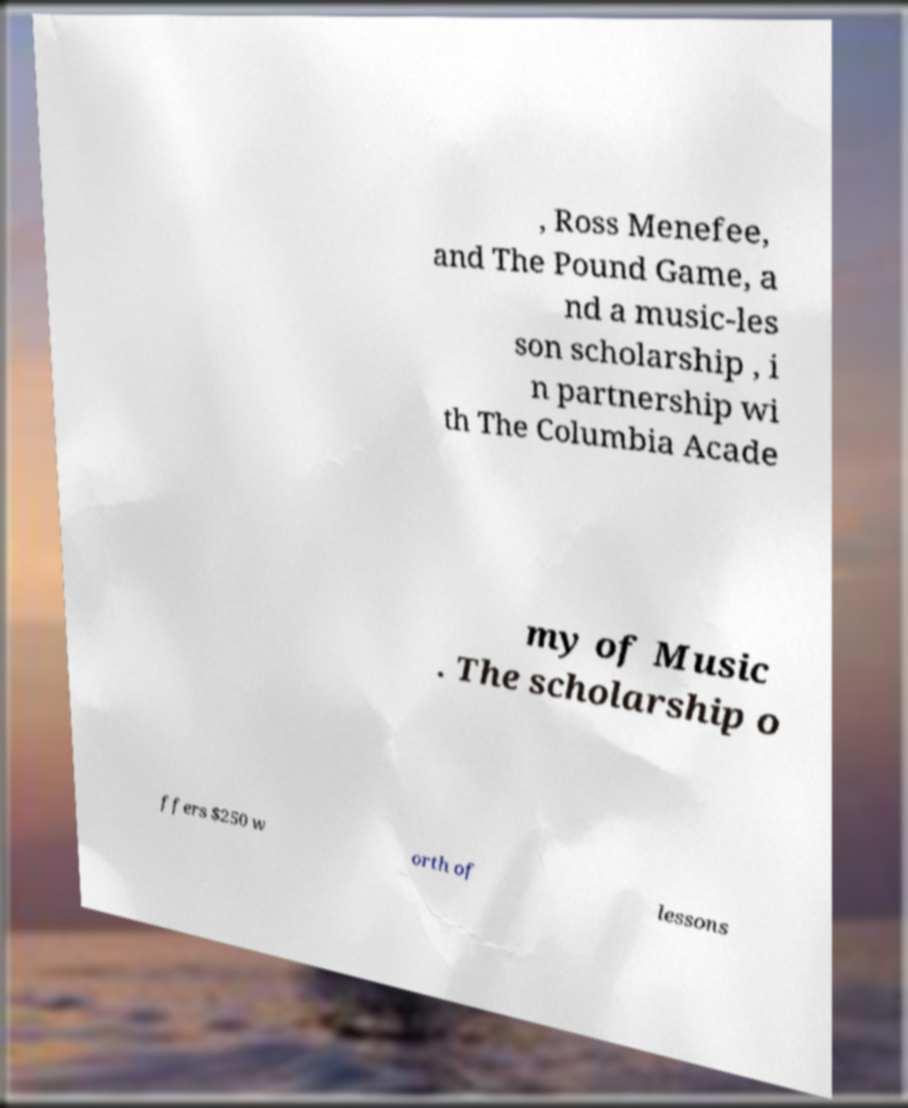For documentation purposes, I need the text within this image transcribed. Could you provide that? , Ross Menefee, and The Pound Game, a nd a music-les son scholarship , i n partnership wi th The Columbia Acade my of Music . The scholarship o ffers $250 w orth of lessons 